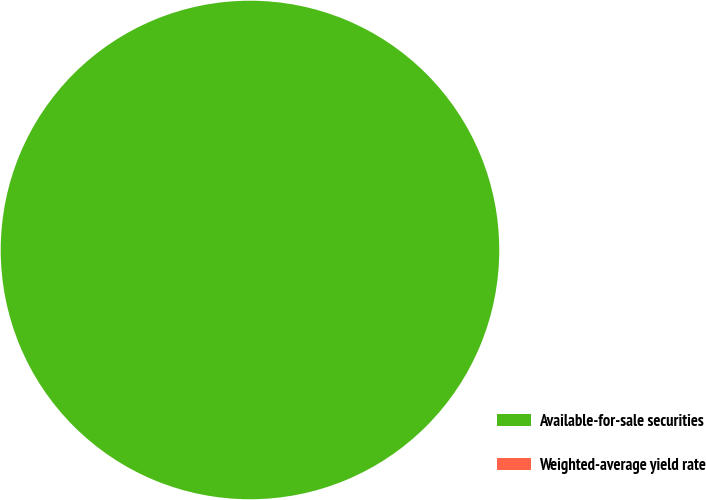Convert chart to OTSL. <chart><loc_0><loc_0><loc_500><loc_500><pie_chart><fcel>Available-for-sale securities<fcel>Weighted-average yield rate<nl><fcel>100.0%<fcel>0.0%<nl></chart> 